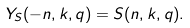Convert formula to latex. <formula><loc_0><loc_0><loc_500><loc_500>Y _ { S } ( - n , k , q ) = S ( n , k , q ) .</formula> 